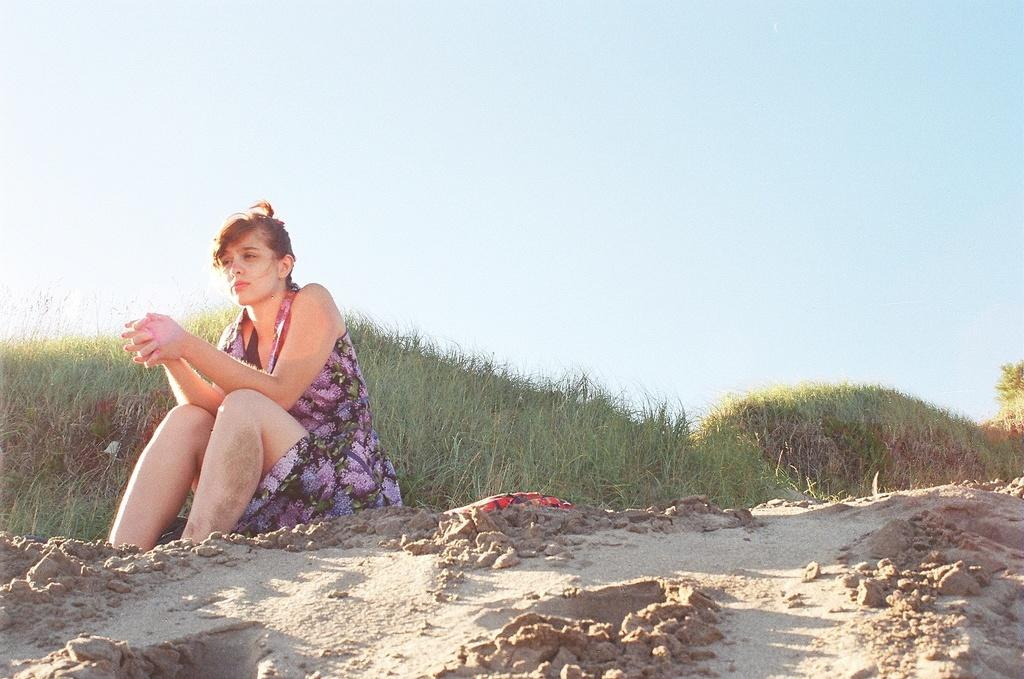What is the lady in the image doing? There is a lady sitting in the image. What type of terrain is visible in the image? There is sand on the ground in the image, and there is also grass present. What can be seen in the background of the image? The sky is visible in the background of the image. What type of test is the lady conducting in the image? There is no indication in the image that the lady is conducting a test, as she is simply sitting. 